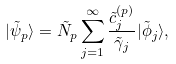<formula> <loc_0><loc_0><loc_500><loc_500>| \tilde { \psi } _ { p } \rangle = \tilde { N } _ { p } \sum _ { j = 1 } ^ { \infty } \frac { \tilde { c } ^ { ( p ) } _ { j } } { \tilde { \gamma } _ { j } } | \tilde { \phi } _ { j } \rangle ,</formula> 